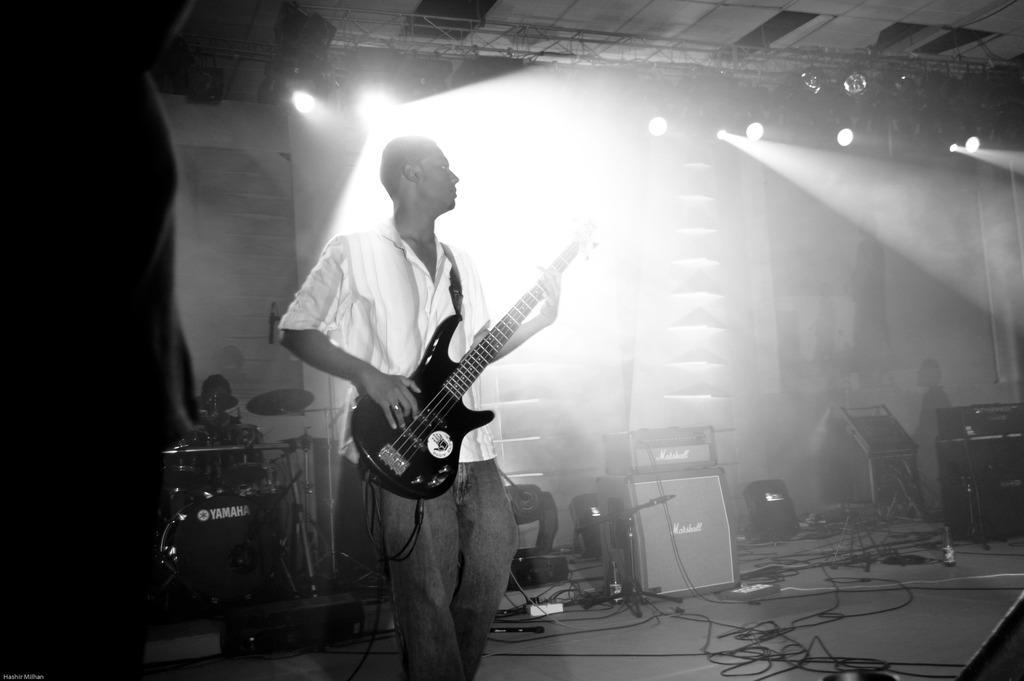Can you describe this image briefly? In the picture we can see a man standing and holding a guitar which is black in color, and a man is wearing a white shirt in the background we can see an orchestra systems, sound boxes and lights with smoke , the lights are fixed to the stand on the ceiling. 